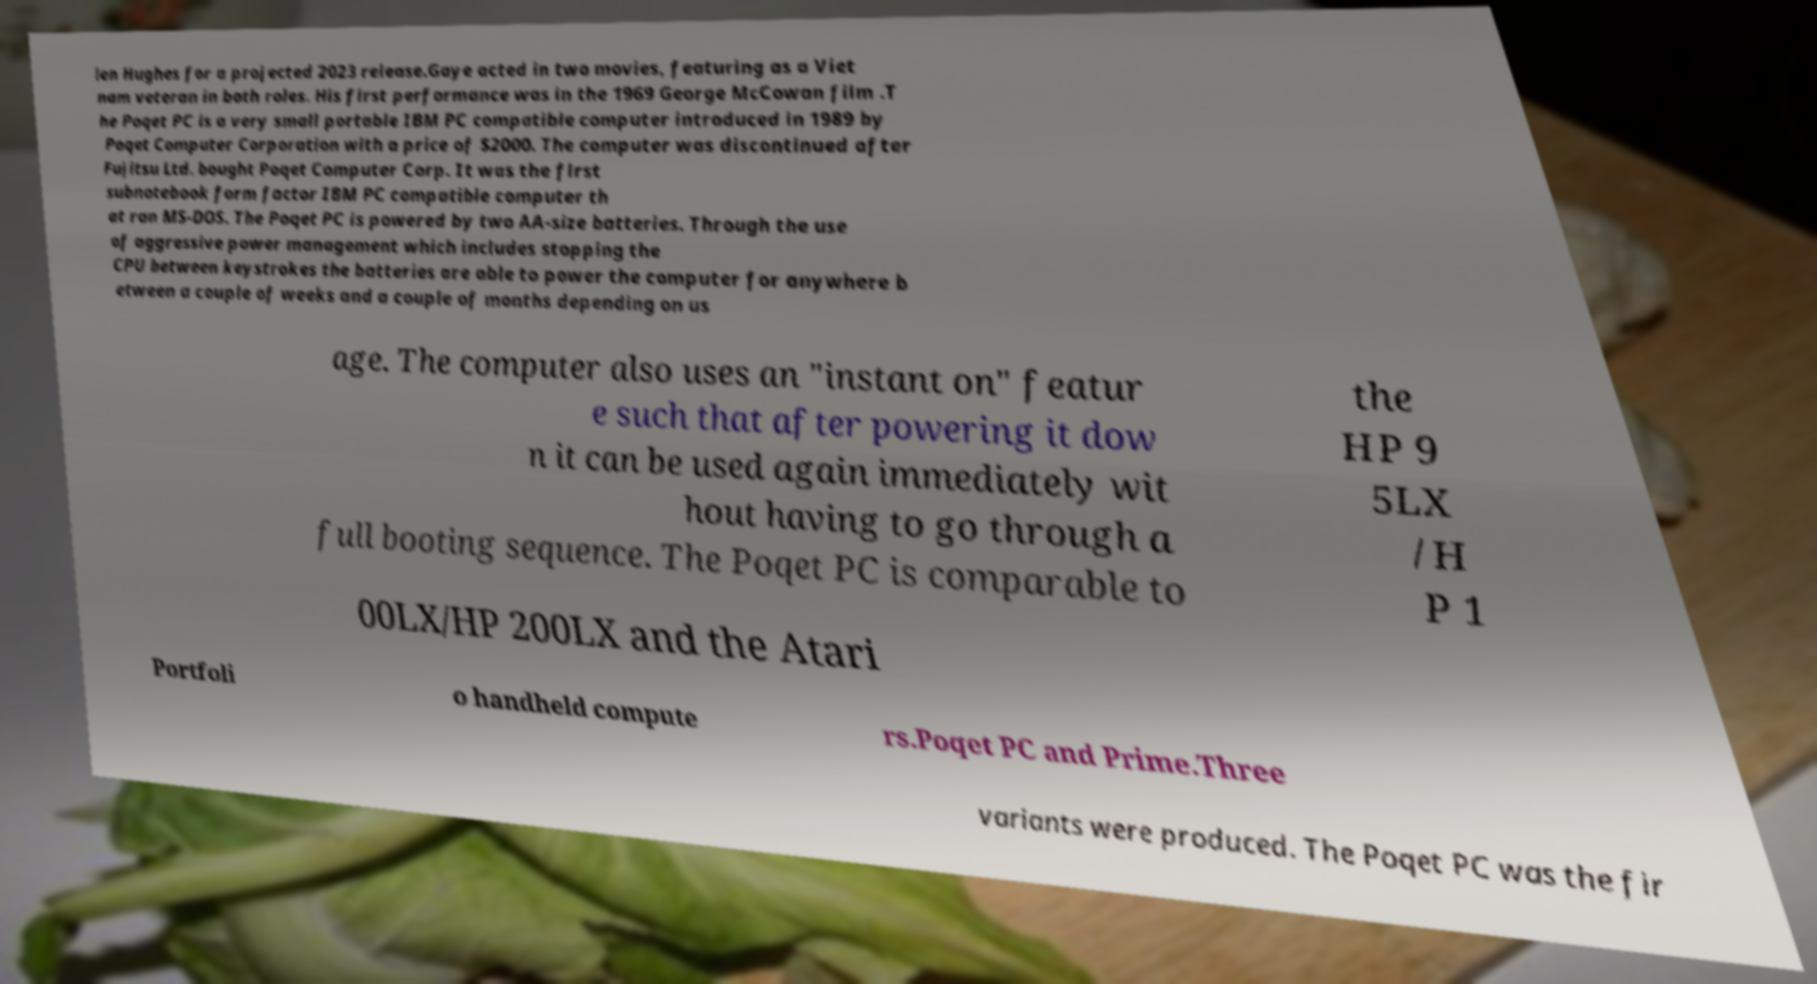Could you assist in decoding the text presented in this image and type it out clearly? len Hughes for a projected 2023 release.Gaye acted in two movies, featuring as a Viet nam veteran in both roles. His first performance was in the 1969 George McCowan film .T he Poqet PC is a very small portable IBM PC compatible computer introduced in 1989 by Poqet Computer Corporation with a price of $2000. The computer was discontinued after Fujitsu Ltd. bought Poqet Computer Corp. It was the first subnotebook form factor IBM PC compatible computer th at ran MS-DOS. The Poqet PC is powered by two AA-size batteries. Through the use of aggressive power management which includes stopping the CPU between keystrokes the batteries are able to power the computer for anywhere b etween a couple of weeks and a couple of months depending on us age. The computer also uses an "instant on" featur e such that after powering it dow n it can be used again immediately wit hout having to go through a full booting sequence. The Poqet PC is comparable to the HP 9 5LX /H P 1 00LX/HP 200LX and the Atari Portfoli o handheld compute rs.Poqet PC and Prime.Three variants were produced. The Poqet PC was the fir 